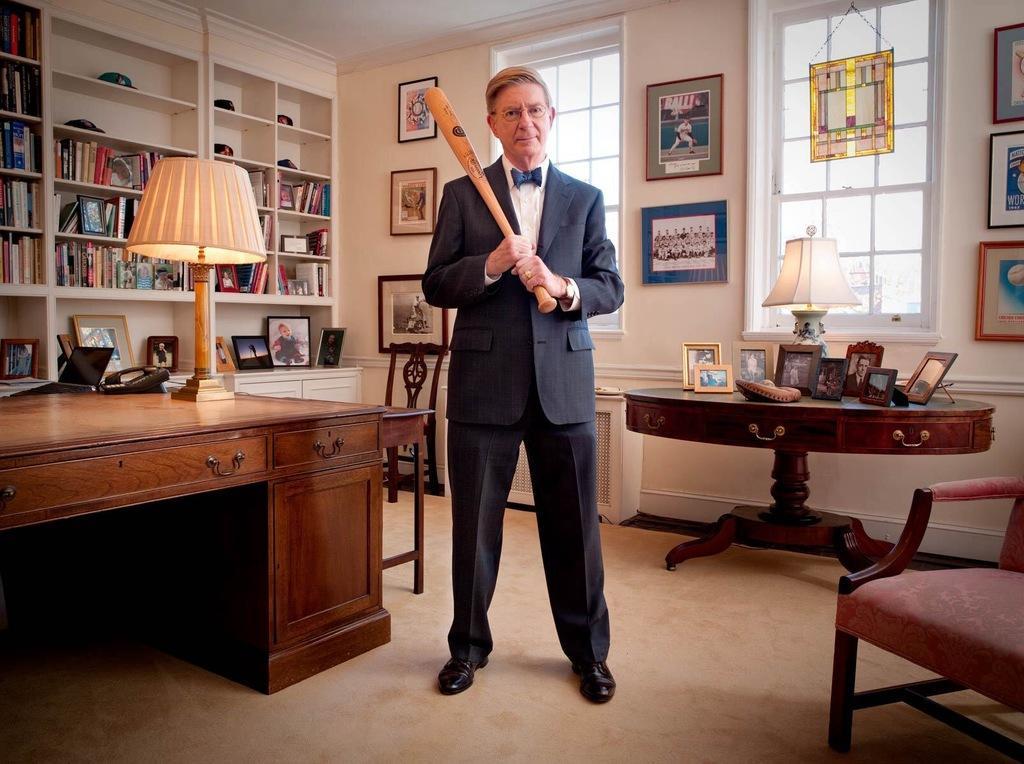Could you give a brief overview of what you see in this image? In the middle of the image there is a man , he is holding the baseball bat, at the left there is a lamp, telephone on the desk, at the right there are lamp, photo frames on the table and a chair in the front. At the back there is a window, there are books and photo frames in the shelf and there are photo frames on the wall. 